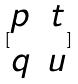Convert formula to latex. <formula><loc_0><loc_0><loc_500><loc_500>[ \begin{matrix} p & t \\ q & u \end{matrix} ]</formula> 